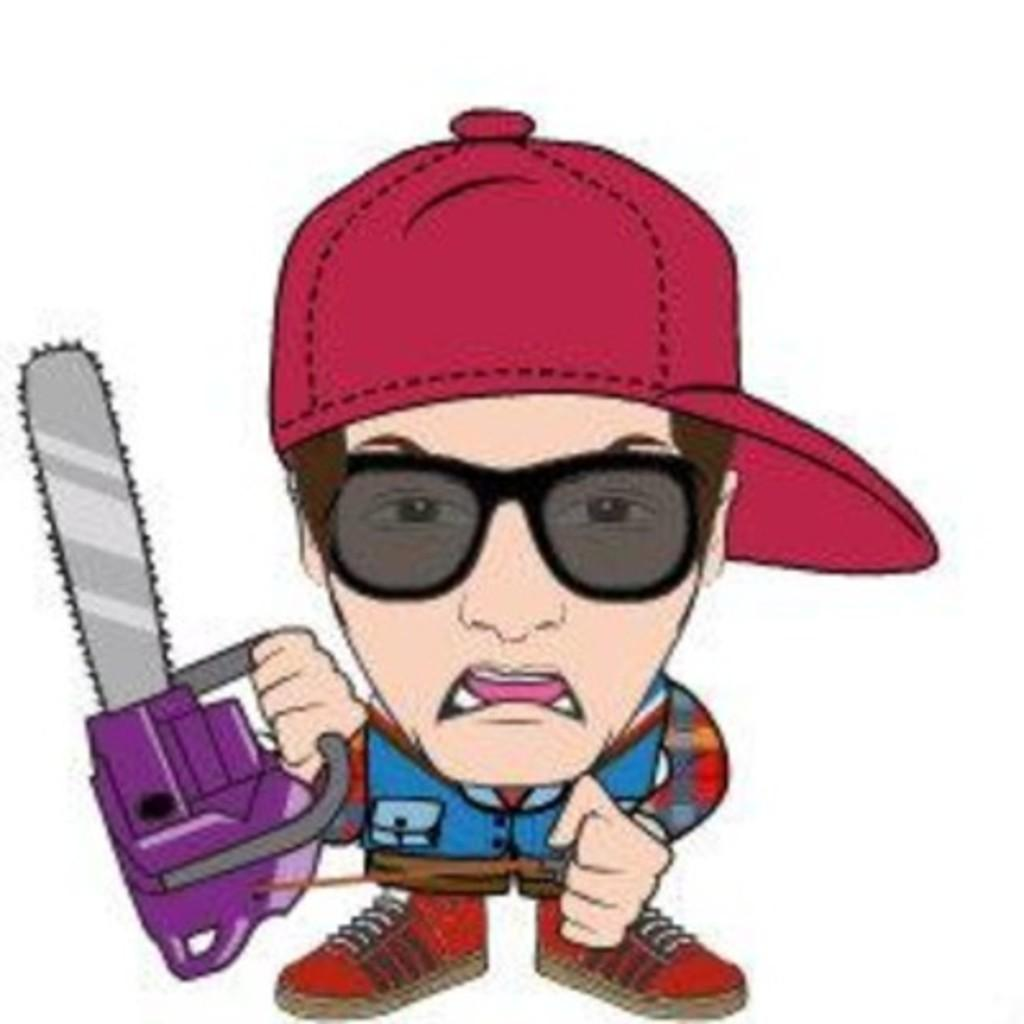What type of image is this? The image appears to be animated. Can you describe the person in the image? There is a man in the image. What is the man wearing? The man is wearing a shirt, shoes, and a cap. What is the man holding in the image? The man is holding a machine. What type of fork can be seen in the image? There is no fork present in the image. What is the zinc content of the machine the man is holding? The image does not provide information about the zinc content of the machine, nor is there any indication that zinc is relevant to the image. 